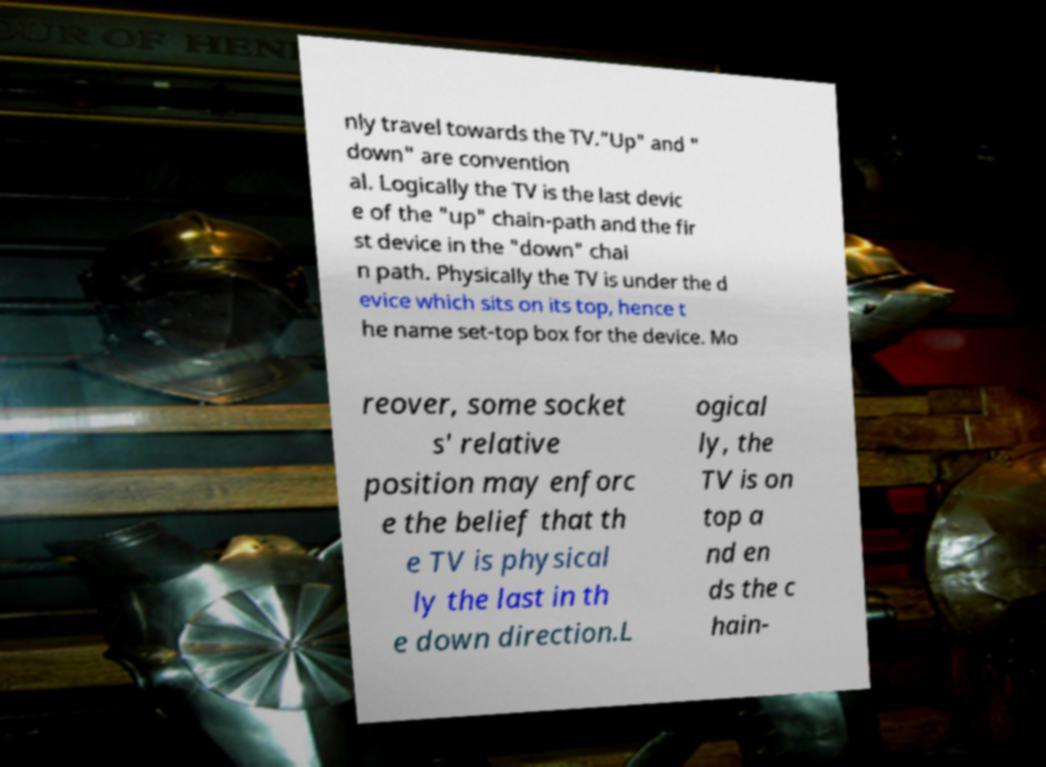For documentation purposes, I need the text within this image transcribed. Could you provide that? nly travel towards the TV."Up" and " down" are convention al. Logically the TV is the last devic e of the "up" chain-path and the fir st device in the "down" chai n path. Physically the TV is under the d evice which sits on its top, hence t he name set-top box for the device. Mo reover, some socket s' relative position may enforc e the belief that th e TV is physical ly the last in th e down direction.L ogical ly, the TV is on top a nd en ds the c hain- 